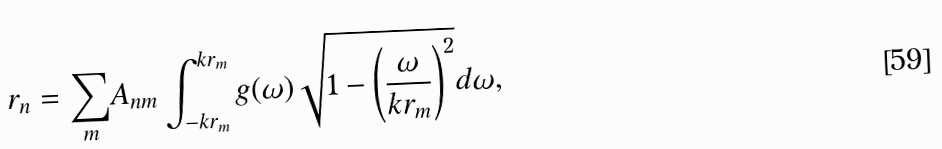Convert formula to latex. <formula><loc_0><loc_0><loc_500><loc_500>r _ { n } = { \sum _ { m } } A _ { n m } \int _ { - k r _ { m } } ^ { k r _ { m } } g ( \omega ) \sqrt { 1 - \left ( \frac { \omega } { k r _ { m } } \right ) ^ { 2 } } d \omega ,</formula> 